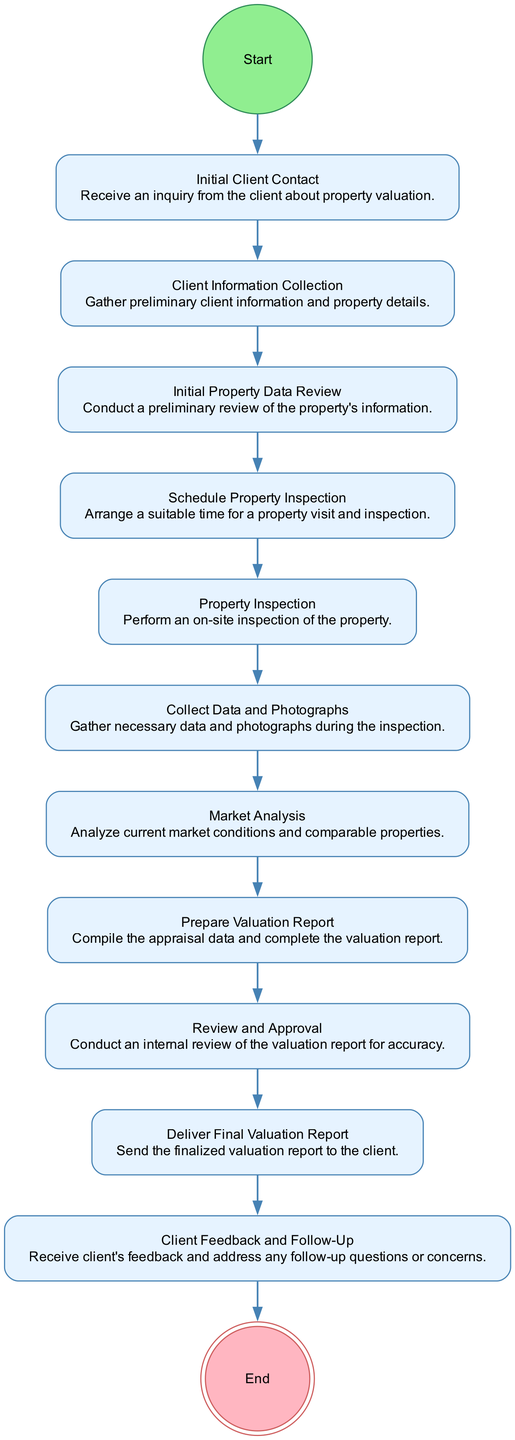What is the first action in the workflow? The diagram lists the "Initial Client Contact" as the first action node after the start, which indicates the beginning of the workflow related to property valuation inquiries.
Answer: Initial Client Contact How many actions are there in the workflow? By counting the nodes in the diagram, there are a total of 11 action nodes before reaching the final node, "End."
Answer: 11 What action follows "Market Analysis"? "Prepare Valuation Report" directly follows "Market Analysis" as represented by the connecting edge in the diagram, indicating the workflow's progression after market conditions are analyzed.
Answer: Prepare Valuation Report Which action is the last before delivering the report? The last action before the "Deliver Final Valuation Report" is "Review and Approval," which signifies that the report undergoes an internal review before it is sent to the client.
Answer: Review and Approval What is the end point of the workflow? The final node in the workflow is labeled "End," indicating the completion of the property valuation inquiry process, concluding the series of actions defined in the diagram.
Answer: End What action is conducted after "Client Information Collection"? The next action following "Client Information Collection" is "Initial Property Data Review," representing a sequential step in the workflow where property specifics are preliminarily assessed.
Answer: Initial Property Data Review What color represents the final node in the diagram? The final node, "End," is represented in a double circle and is filled with a light pink color, distinctly indicating the conclusion of the workflow in the diagram.
Answer: Light pink What is the purpose of the "Collect Data and Photographs" action? This action aims to gather necessary information and visual documentation during the property inspection, ensuring thorough information is compiled for the valuation.
Answer: Gather necessary data and photographs Which action requires gathering preliminary client information? The action "Client Information Collection" is specifically designated for gathering essential information from the client to proceed with the valuation process.
Answer: Client Information Collection 